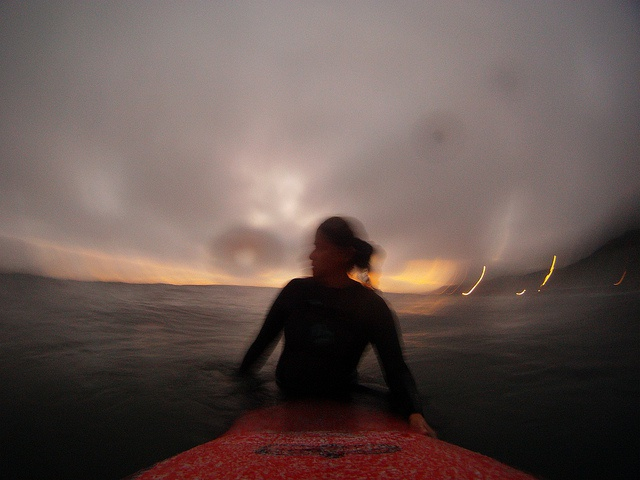Describe the objects in this image and their specific colors. I can see people in gray, black, maroon, and brown tones and surfboard in gray, maroon, black, and brown tones in this image. 